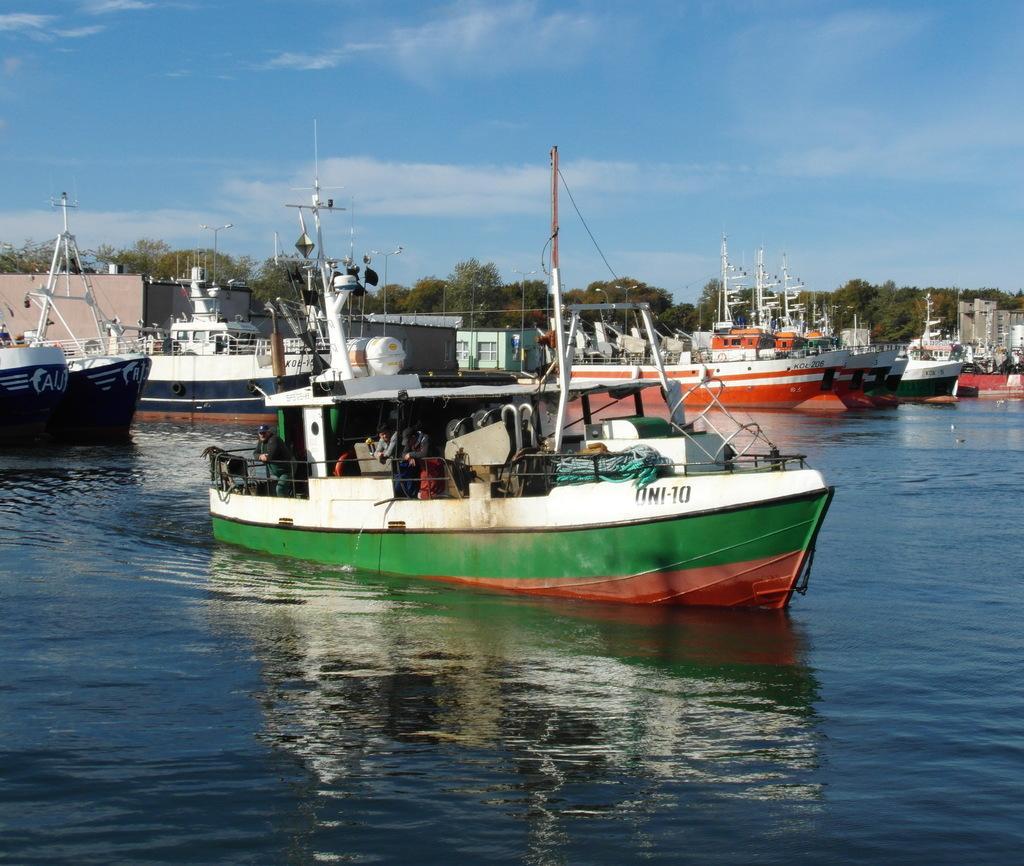Can you describe this image briefly? In this image I can see water and in it I can see number of boats. In the background can see number of trees, clouds and the sky. 